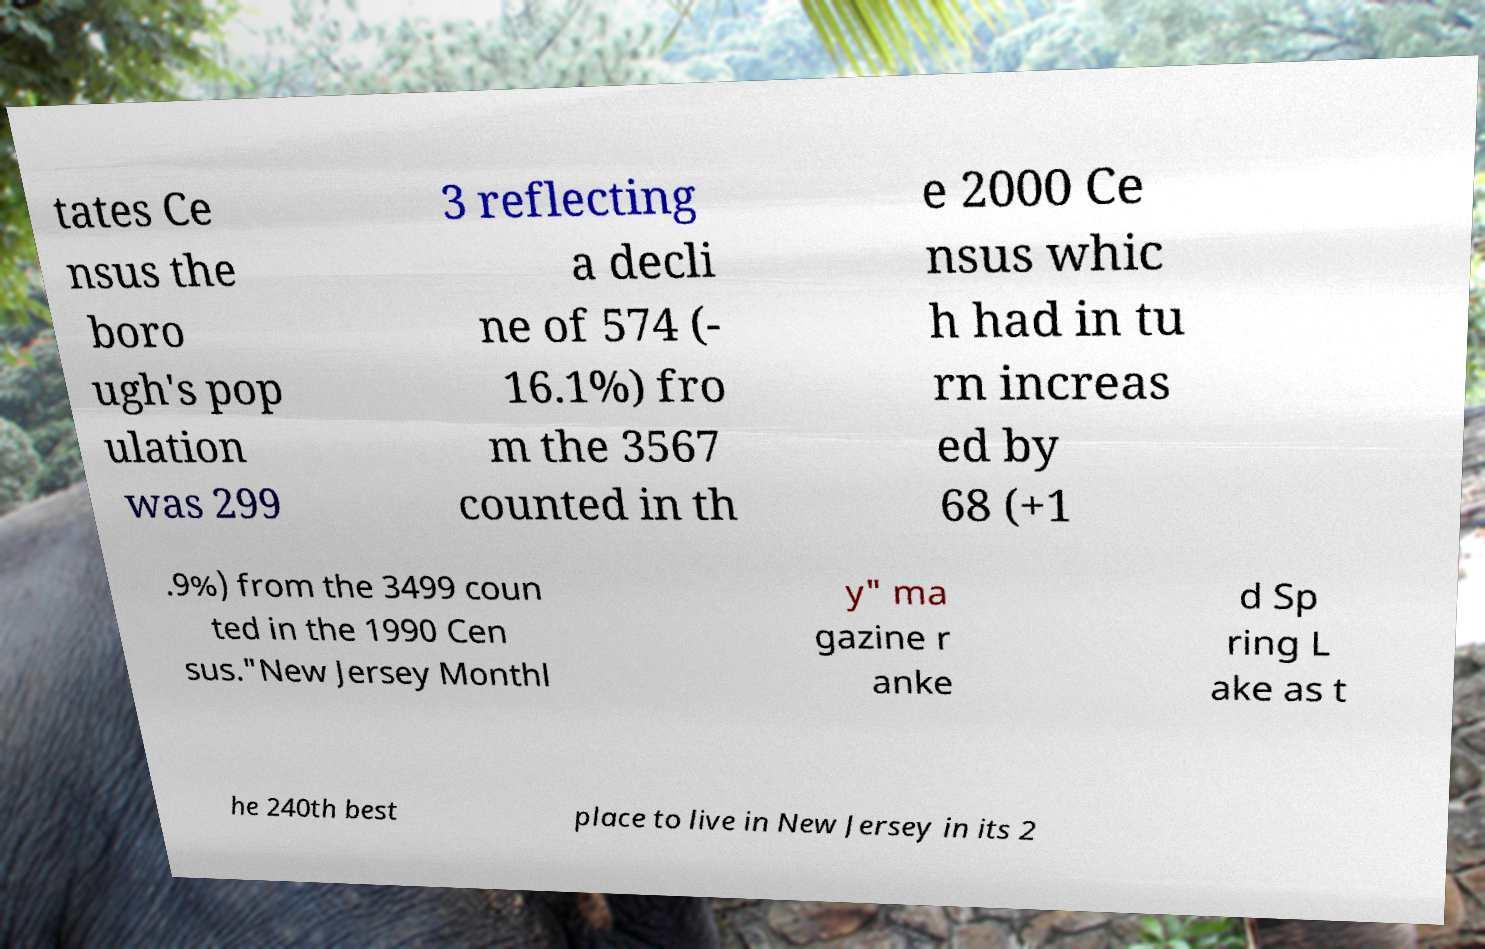Can you read and provide the text displayed in the image?This photo seems to have some interesting text. Can you extract and type it out for me? tates Ce nsus the boro ugh's pop ulation was 299 3 reflecting a decli ne of 574 (- 16.1%) fro m the 3567 counted in th e 2000 Ce nsus whic h had in tu rn increas ed by 68 (+1 .9%) from the 3499 coun ted in the 1990 Cen sus."New Jersey Monthl y" ma gazine r anke d Sp ring L ake as t he 240th best place to live in New Jersey in its 2 